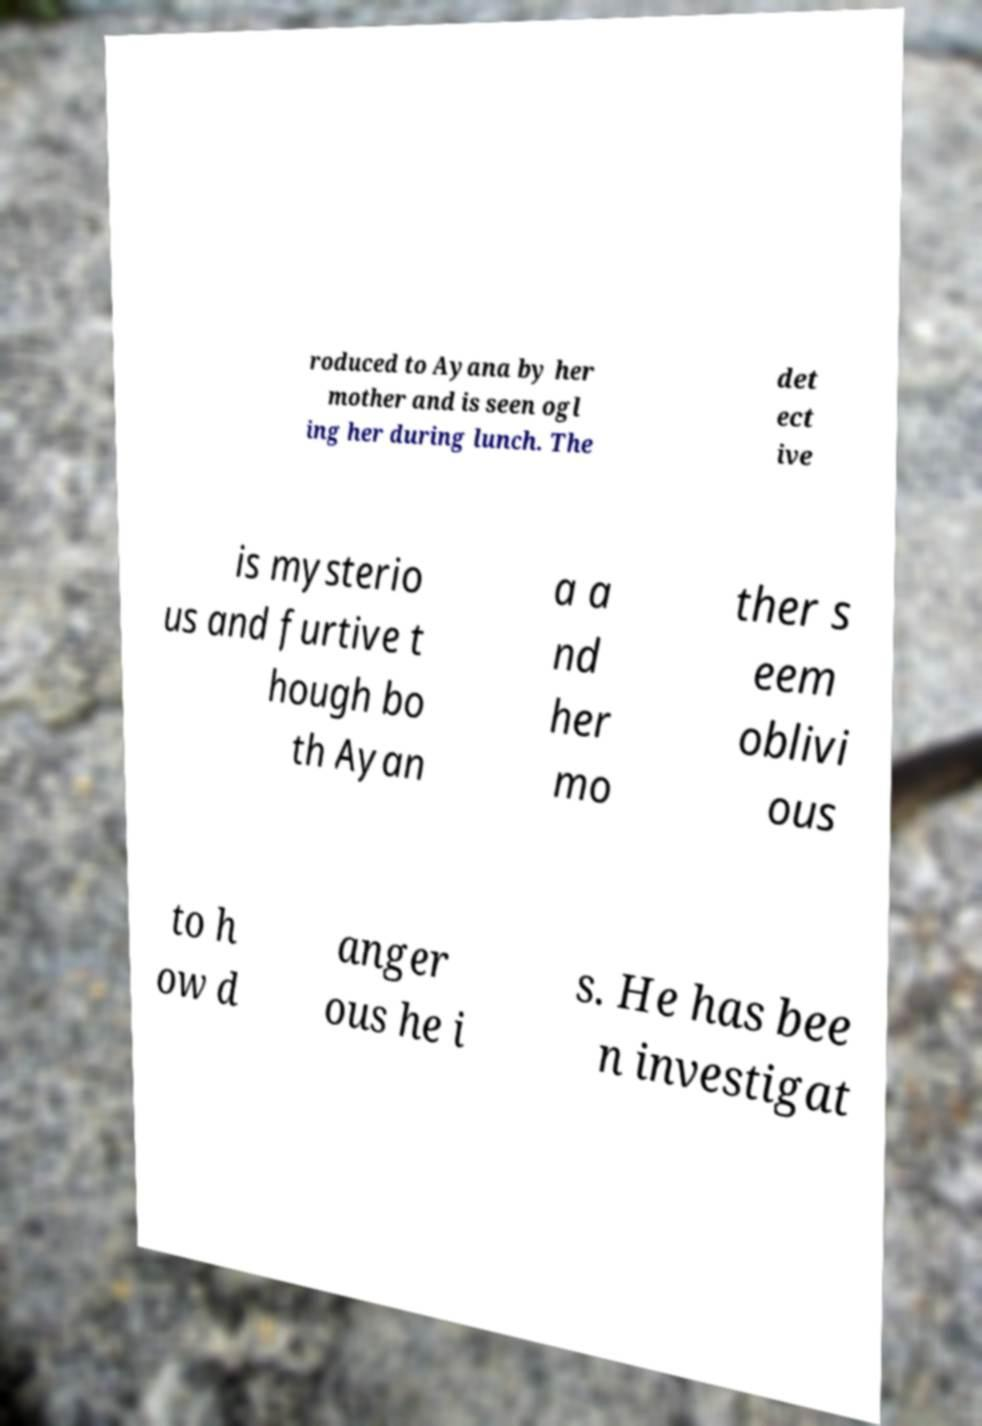Please read and relay the text visible in this image. What does it say? roduced to Ayana by her mother and is seen ogl ing her during lunch. The det ect ive is mysterio us and furtive t hough bo th Ayan a a nd her mo ther s eem oblivi ous to h ow d anger ous he i s. He has bee n investigat 